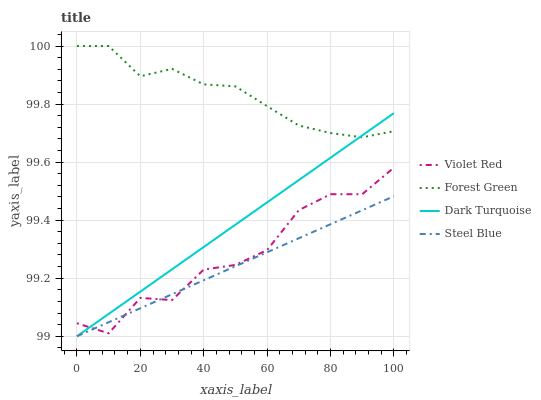Does Steel Blue have the minimum area under the curve?
Answer yes or no. Yes. Does Forest Green have the maximum area under the curve?
Answer yes or no. Yes. Does Violet Red have the minimum area under the curve?
Answer yes or no. No. Does Violet Red have the maximum area under the curve?
Answer yes or no. No. Is Steel Blue the smoothest?
Answer yes or no. Yes. Is Violet Red the roughest?
Answer yes or no. Yes. Is Forest Green the smoothest?
Answer yes or no. No. Is Forest Green the roughest?
Answer yes or no. No. Does Violet Red have the lowest value?
Answer yes or no. No. Does Forest Green have the highest value?
Answer yes or no. Yes. Does Violet Red have the highest value?
Answer yes or no. No. Is Steel Blue less than Forest Green?
Answer yes or no. Yes. Is Forest Green greater than Violet Red?
Answer yes or no. Yes. Does Dark Turquoise intersect Steel Blue?
Answer yes or no. Yes. Is Dark Turquoise less than Steel Blue?
Answer yes or no. No. Is Dark Turquoise greater than Steel Blue?
Answer yes or no. No. Does Steel Blue intersect Forest Green?
Answer yes or no. No. 